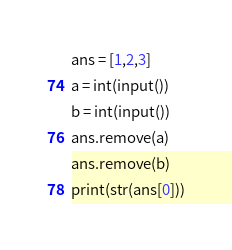Convert code to text. <code><loc_0><loc_0><loc_500><loc_500><_Python_>ans = [1,2,3]
a = int(input())
b = int(input())
ans.remove(a)
ans.remove(b)
print(str(ans[0]))</code> 